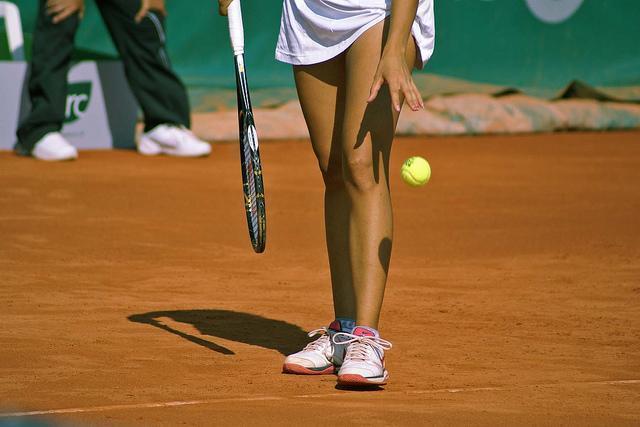What will the person here do next in the game?
Pick the right solution, then justify: 'Answer: answer
Rationale: rationale.'
Options: Serve, rest, quit, return ball. Answer: serve.
Rationale: She is getting ready to hit the ball. 